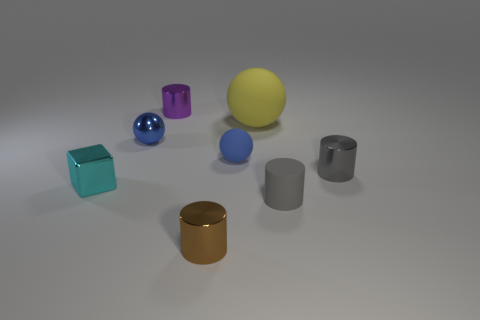Do the tiny metallic cylinder right of the small rubber cylinder and the rubber thing that is to the right of the big yellow rubber ball have the same color?
Ensure brevity in your answer.  Yes. Is there any other thing that has the same color as the metal sphere?
Ensure brevity in your answer.  Yes. Does the tiny metallic thing that is to the right of the tiny brown object have the same color as the tiny rubber cylinder?
Your answer should be very brief. Yes. There is a thing behind the yellow ball; is its size the same as the large thing?
Your response must be concise. No. The rubber object that is the same color as the small metal sphere is what shape?
Ensure brevity in your answer.  Sphere. What is the shape of the brown shiny object?
Give a very brief answer. Cylinder. Is the color of the large rubber ball the same as the small rubber cylinder?
Provide a succinct answer. No. What number of things are shiny cylinders that are behind the brown shiny cylinder or large green rubber cylinders?
Provide a short and direct response. 2. The blue ball that is made of the same material as the cyan object is what size?
Make the answer very short. Small. Are there more tiny purple cylinders that are to the right of the brown metal object than small cyan blocks?
Keep it short and to the point. No. 